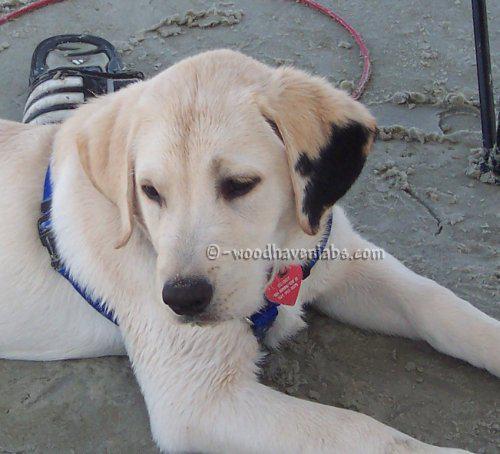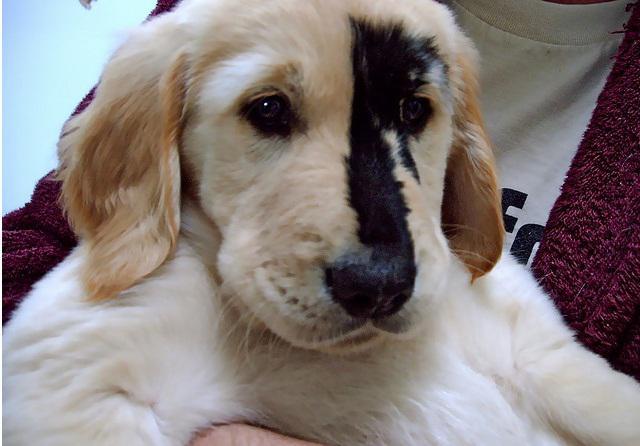The first image is the image on the left, the second image is the image on the right. Examine the images to the left and right. Is the description "A dog has orangish-blond fur and a dark uneven stripe that runs from above one eye to its nose." accurate? Answer yes or no. Yes. The first image is the image on the left, the second image is the image on the right. Examine the images to the left and right. Is the description "There are more animals in the image on the left." accurate? Answer yes or no. No. 